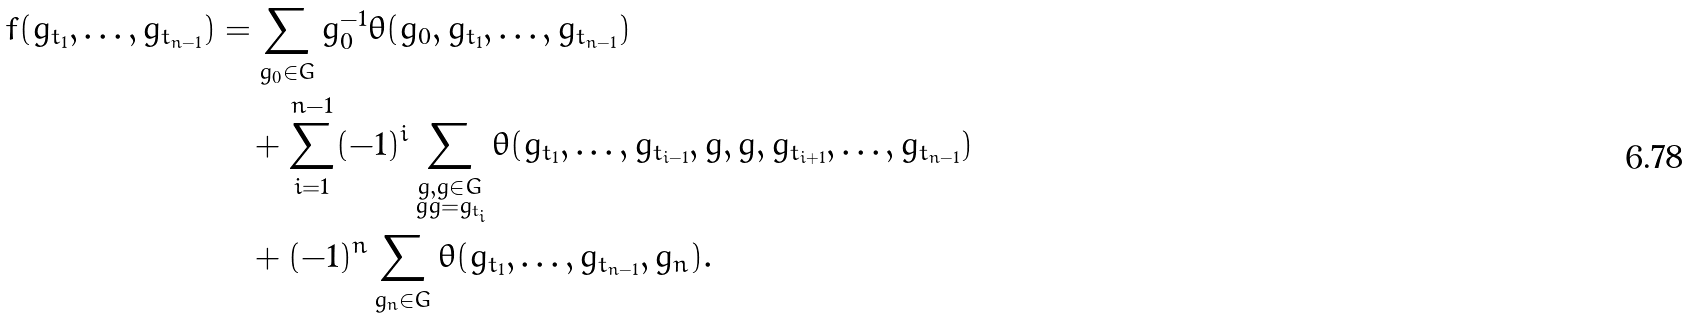Convert formula to latex. <formula><loc_0><loc_0><loc_500><loc_500>f ( g _ { t _ { 1 } } , \dots , g _ { t _ { n - 1 } } ) & = \sum _ { g _ { 0 } \in G } g _ { 0 } ^ { - 1 } \theta ( g _ { 0 } , g _ { t _ { 1 } } , \dots , g _ { t _ { n - 1 } } ) \\ & \quad + \sum _ { i = 1 } ^ { n - 1 } ( - 1 ) ^ { i } \sum _ { \substack { g , \bar { g } \in G \\ g \bar { g } = g _ { t _ { i } } } } \theta ( g _ { t _ { 1 } } , \dots , g _ { t _ { i - 1 } } , g , \bar { g } , g _ { t _ { i + 1 } } , \dots , g _ { t _ { n - 1 } } ) \\ & \quad + ( - 1 ) ^ { n } \sum _ { g _ { n } \in G } \theta ( g _ { t _ { 1 } } , \dots , g _ { t _ { n - 1 } } , g _ { n } ) .</formula> 